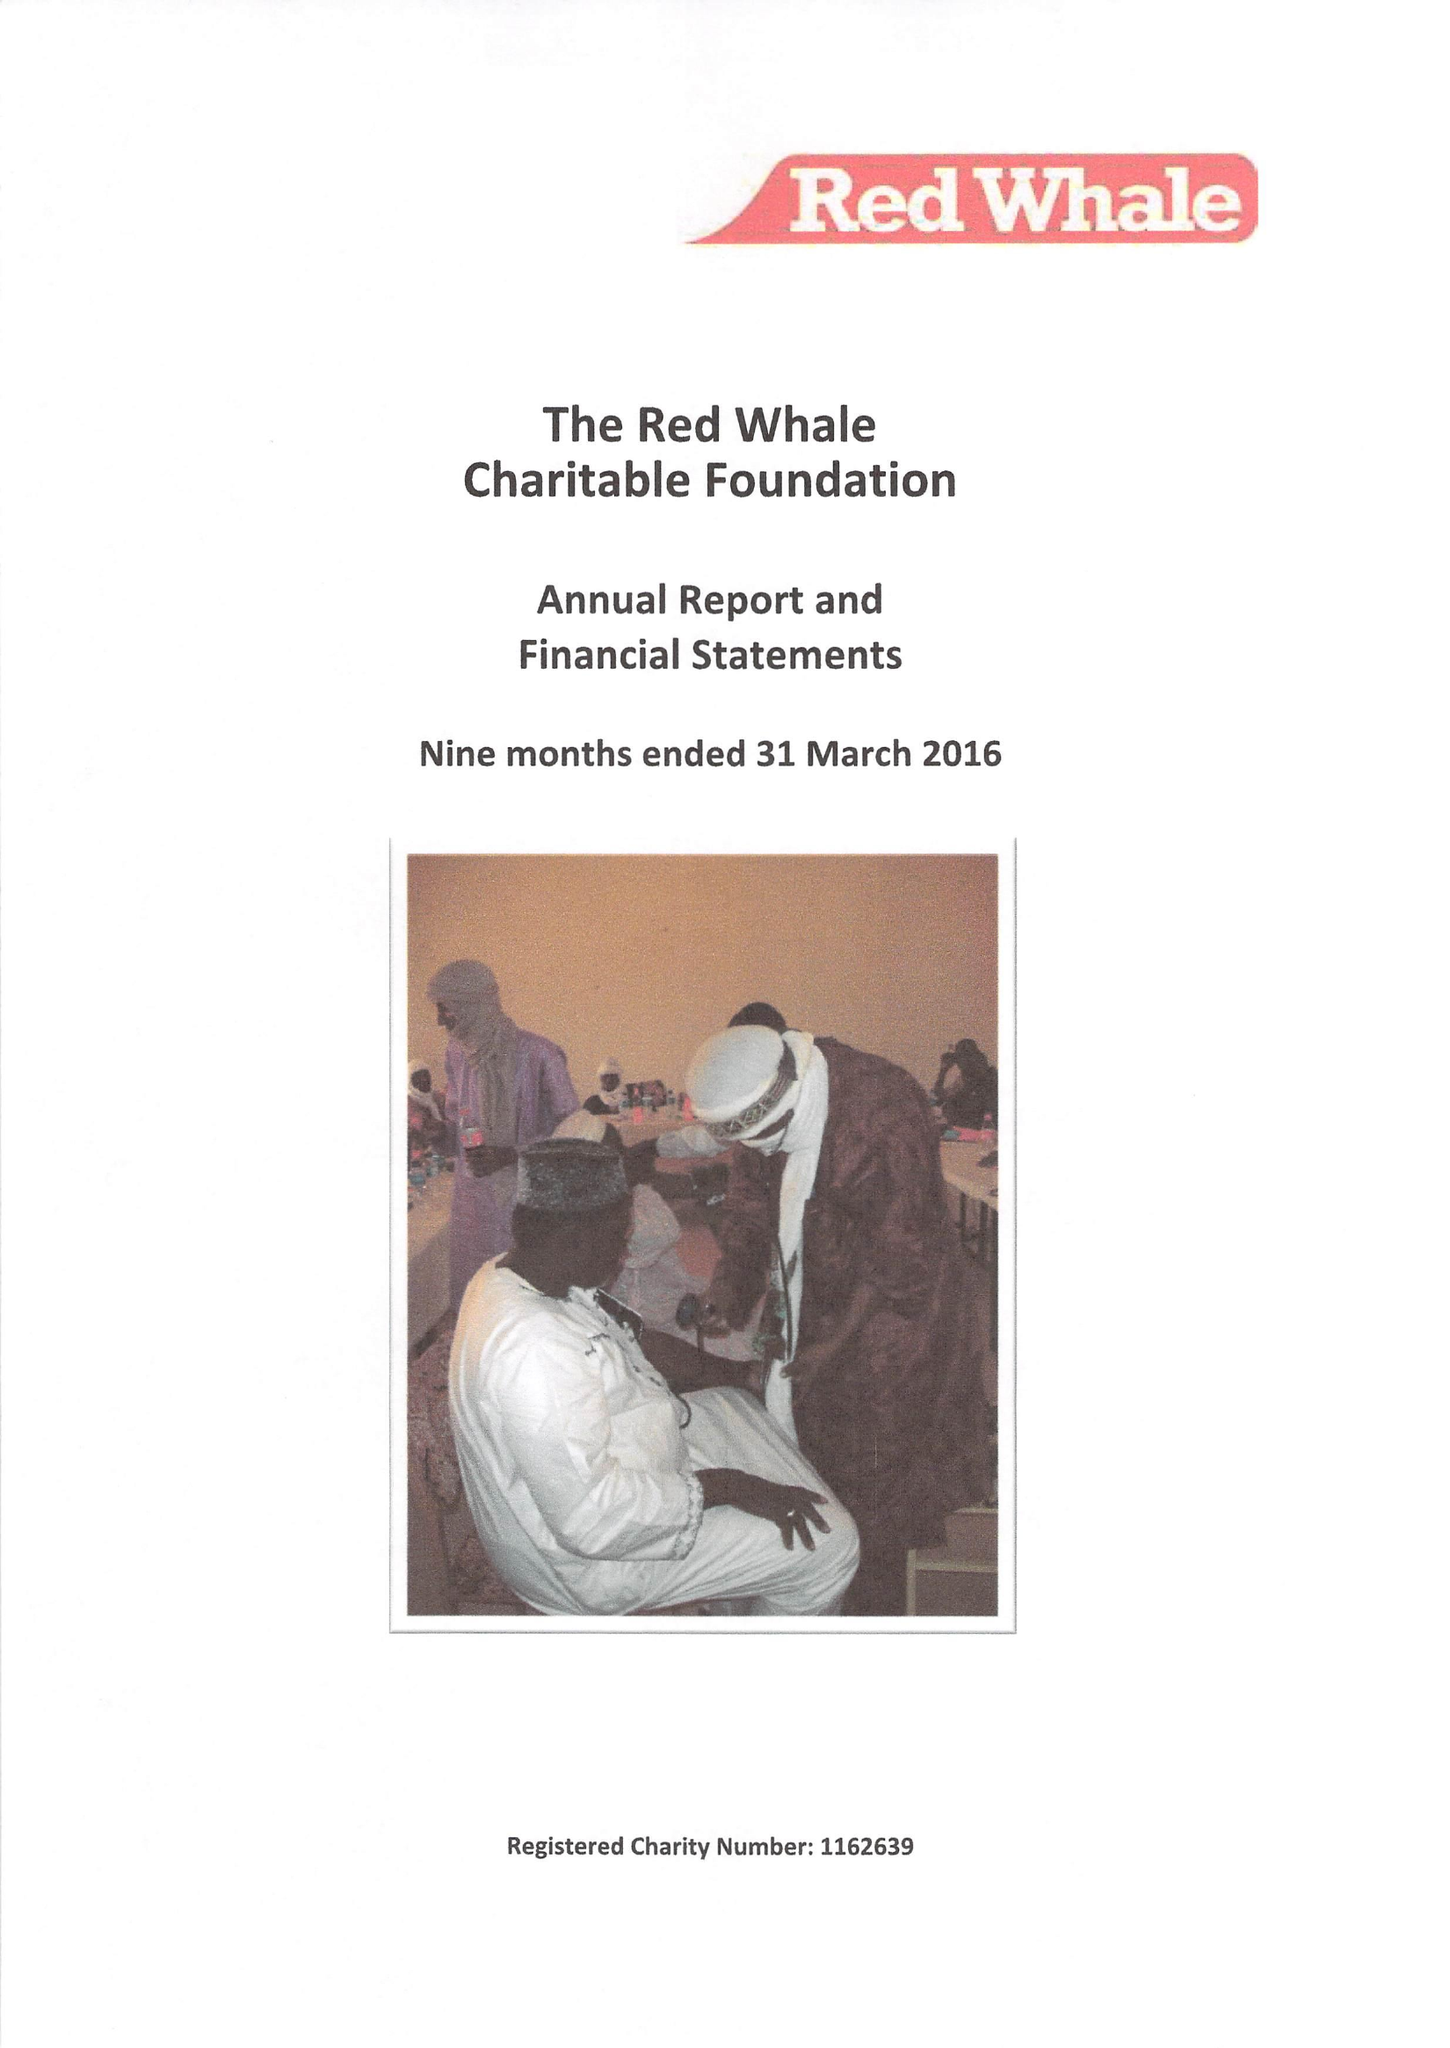What is the value for the charity_name?
Answer the question using a single word or phrase. The Red Whale Charitable Foundation 